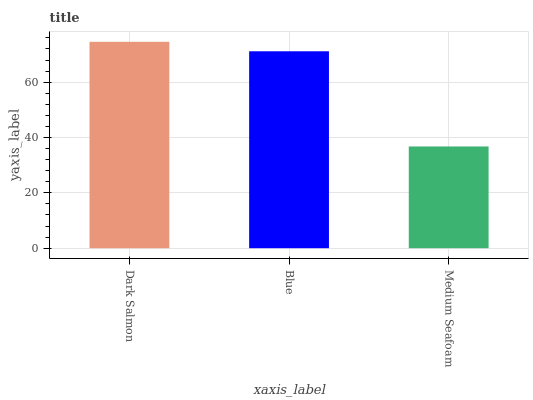Is Medium Seafoam the minimum?
Answer yes or no. Yes. Is Dark Salmon the maximum?
Answer yes or no. Yes. Is Blue the minimum?
Answer yes or no. No. Is Blue the maximum?
Answer yes or no. No. Is Dark Salmon greater than Blue?
Answer yes or no. Yes. Is Blue less than Dark Salmon?
Answer yes or no. Yes. Is Blue greater than Dark Salmon?
Answer yes or no. No. Is Dark Salmon less than Blue?
Answer yes or no. No. Is Blue the high median?
Answer yes or no. Yes. Is Blue the low median?
Answer yes or no. Yes. Is Medium Seafoam the high median?
Answer yes or no. No. Is Dark Salmon the low median?
Answer yes or no. No. 